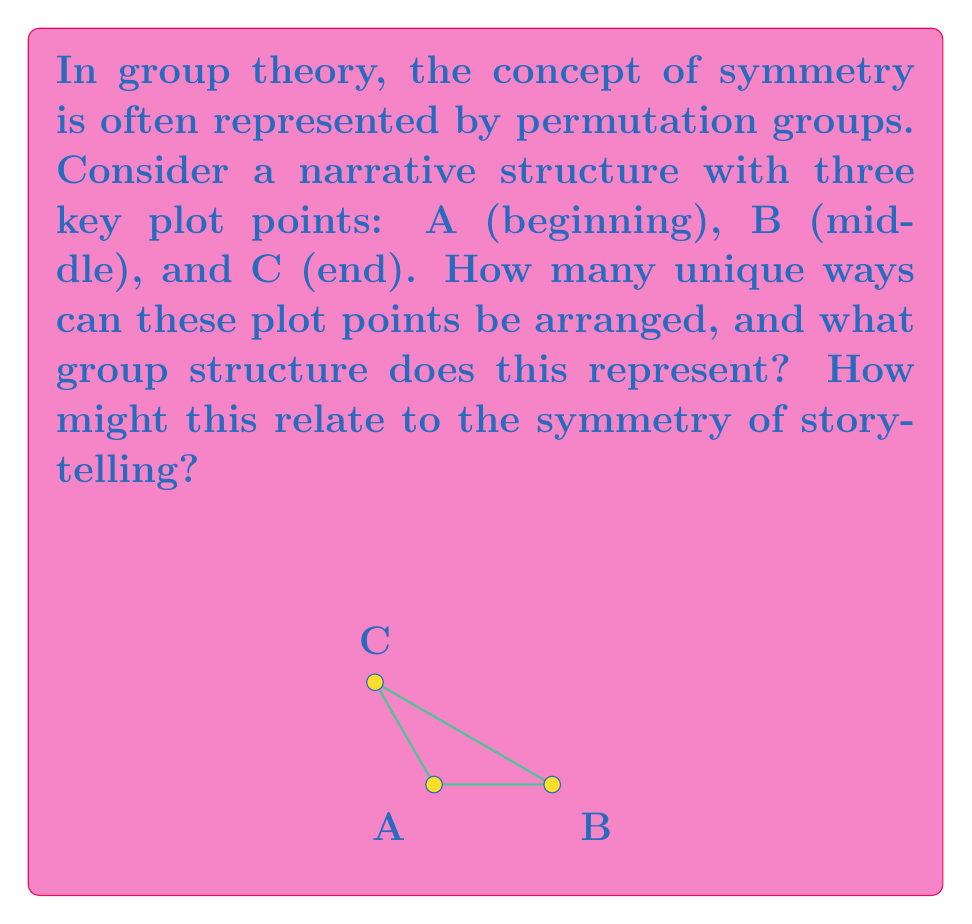Provide a solution to this math problem. Let's approach this step-by-step:

1) First, we need to count the number of possible arrangements:
   - ABC, ACB, BAC, BCA, CAB, CBA
   There are 6 possible arrangements in total.

2) This set of permutations forms a group under composition, known as the symmetric group $S_3$.

3) The order of this group is 6, which corresponds to $3!$ (3 factorial).

4) The group $S_3$ has the following properties:
   - Identity element: $e$ (ABC)
   - Cyclic subgroup of order 3: $(ABC, BCA, CAB)$
   - Three elements of order 2: $(AB), (BC), (AC)$

5) In terms of symmetry, $S_3$ is isomorphic to the dihedral group $D_3$, which represents the symmetries of an equilateral triangle.

6) Relating this to narrative structure:
   - The identity element $e$ represents the "standard" narrative order.
   - The cyclic subgroup represents circular narratives or time loops.
   - The order-2 elements represent narratives with a single flashback or flash-forward.

7) The symmetry in $S_3$ reflects the flexibility in storytelling:
   - All elements are generated by combinations of simple transpositions (swapping two elements).
   - This mirrors how complex narrative structures can be built from simple reorderings of events.

8) The group structure provides a mathematical framework for analyzing narrative symmetry:
   - Closure: Any combination of reorderings results in a valid ordering.
   - Associativity: The order of applying multiple reorderings doesn't matter.
   - Identity: There's a "standard" ordering that leaves the narrative unchanged.
   - Inverse: Any reordering can be "undone" to return to the original order.
Answer: $S_3$, isomorphic to $D_3$ 